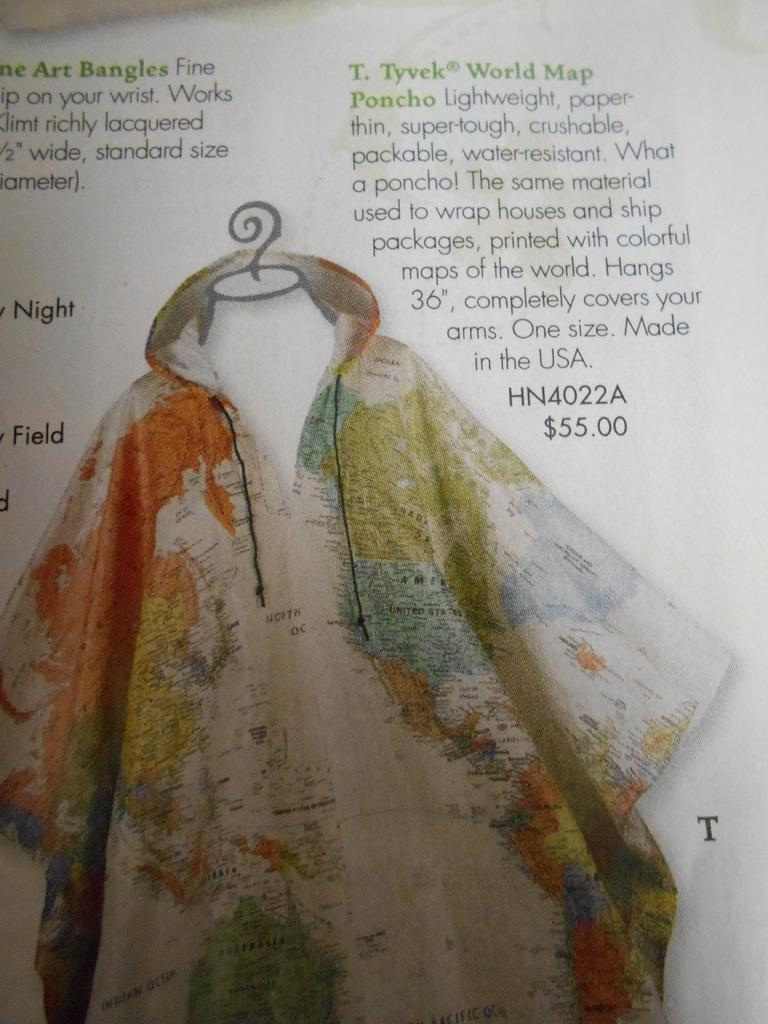What is the medium of the image? The image is on a paper. What shape does the image take? The image is in the shape of a shirt. What design is featured on the shirt? The shirt has a world map on it. What is the general term for the materials in the image? There is matter in the image. What type of church is depicted on the shirt in the image? There is no church depicted on the shirt in the image; it features a world map. Can you tell me the name of the secretary who works at the location shown in the image? There is no location or secretary mentioned in the image; it is a shirt with a world map on it. 